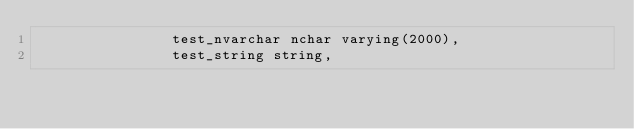<code> <loc_0><loc_0><loc_500><loc_500><_SQL_>				test_nvarchar nchar varying(2000),
				test_string string,</code> 